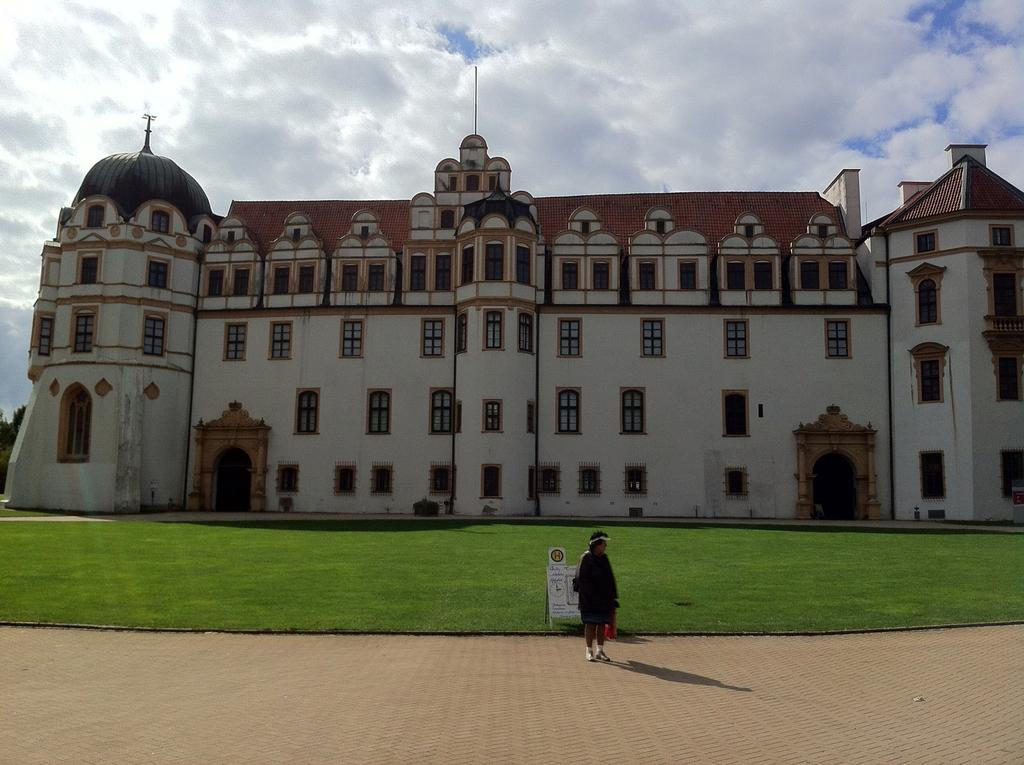Who or what is the main subject in the middle of the image? There is a person in the middle of the image. What is located behind the person? There are boards visible behind the person. What can be seen in the distance in the image? There is a building in the background of the image. What is visible at the top of the image? The sky is visible at the top of the image. What type of egg is being used as a prop in the image? There is no egg present in the image. What type of trousers is the person wearing in the image? The provided facts do not mention the type of trousers the person is wearing, so we cannot answer this question definitively. 